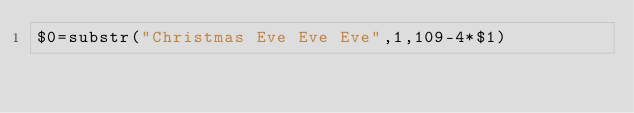Convert code to text. <code><loc_0><loc_0><loc_500><loc_500><_Awk_>$0=substr("Christmas Eve Eve Eve",1,109-4*$1)</code> 